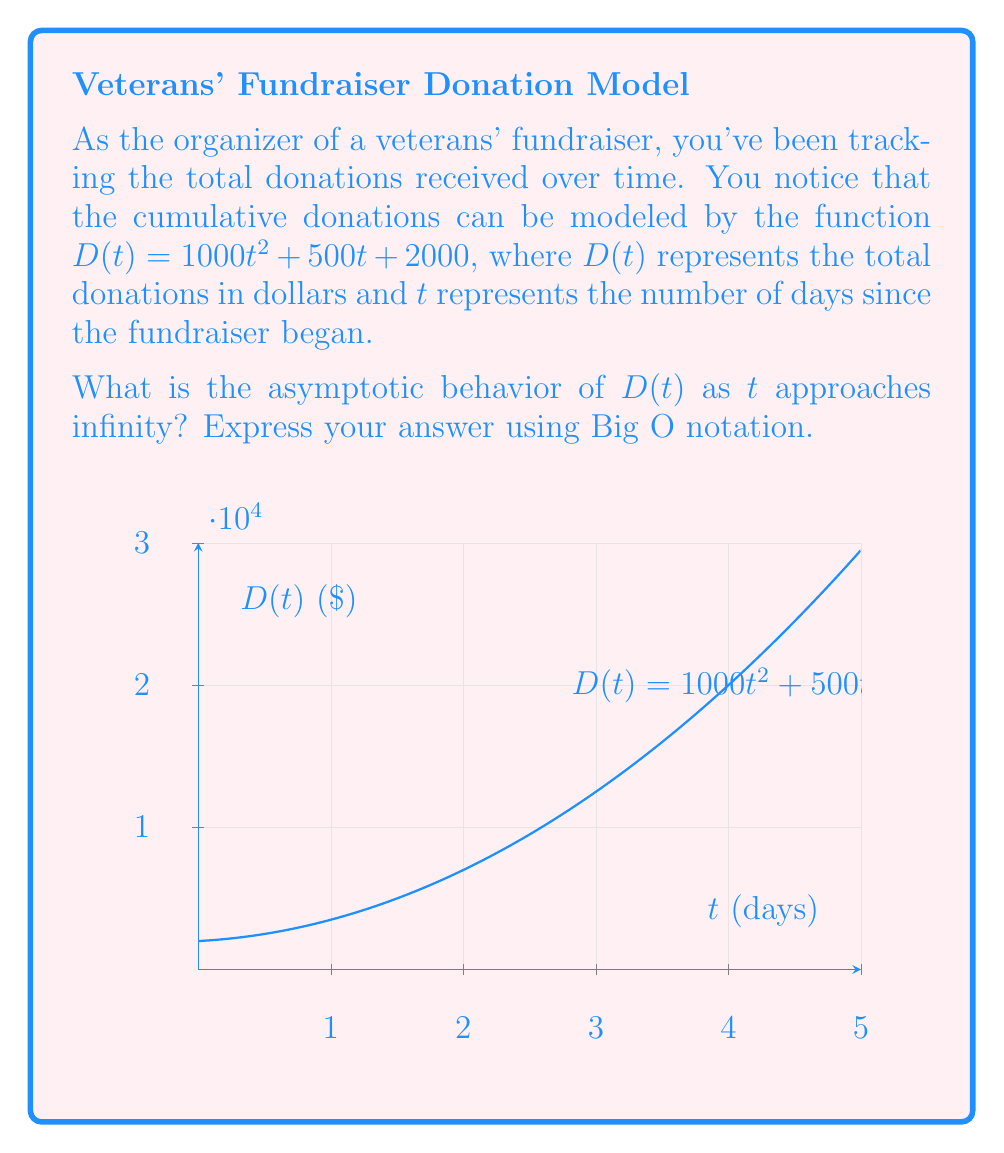Can you solve this math problem? To determine the asymptotic behavior of $D(t)$ as $t$ approaches infinity, we need to identify the dominant term in the function as $t$ grows very large. Let's analyze each term:

1) $1000t^2$: This is a quadratic term.
2) $500t$: This is a linear term.
3) $2000$: This is a constant term.

As $t$ becomes very large:

1) The quadratic term $1000t^2$ will grow much faster than the other terms.
2) The linear term $500t$ will become insignificant compared to $1000t^2$.
3) The constant term $2000$ will become negligible.

Therefore, for large values of $t$, the function $D(t)$ will behave asymptotically like $1000t^2$.

In Big O notation, we ignore constant factors. So, $1000t^2$ is equivalent to $t^2$ in terms of asymptotic growth.

Thus, we can conclude that $D(t) = O(t^2)$ as $t$ approaches infinity.

This means that the growth rate of donations is quadratic in the long term, indicating that the fundraising efforts are accelerating over time.
Answer: $O(t^2)$ 